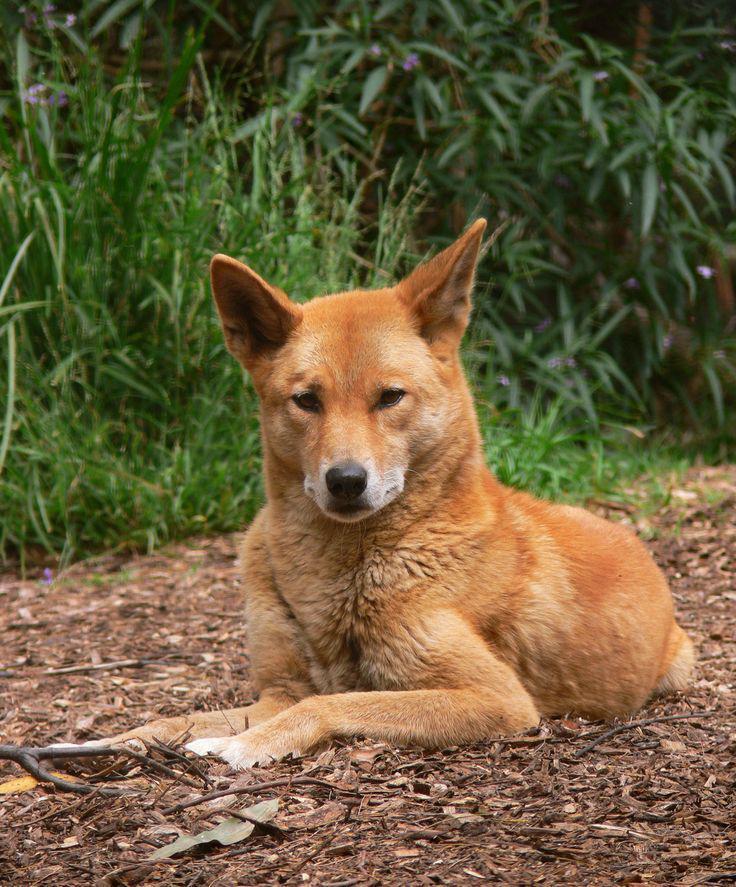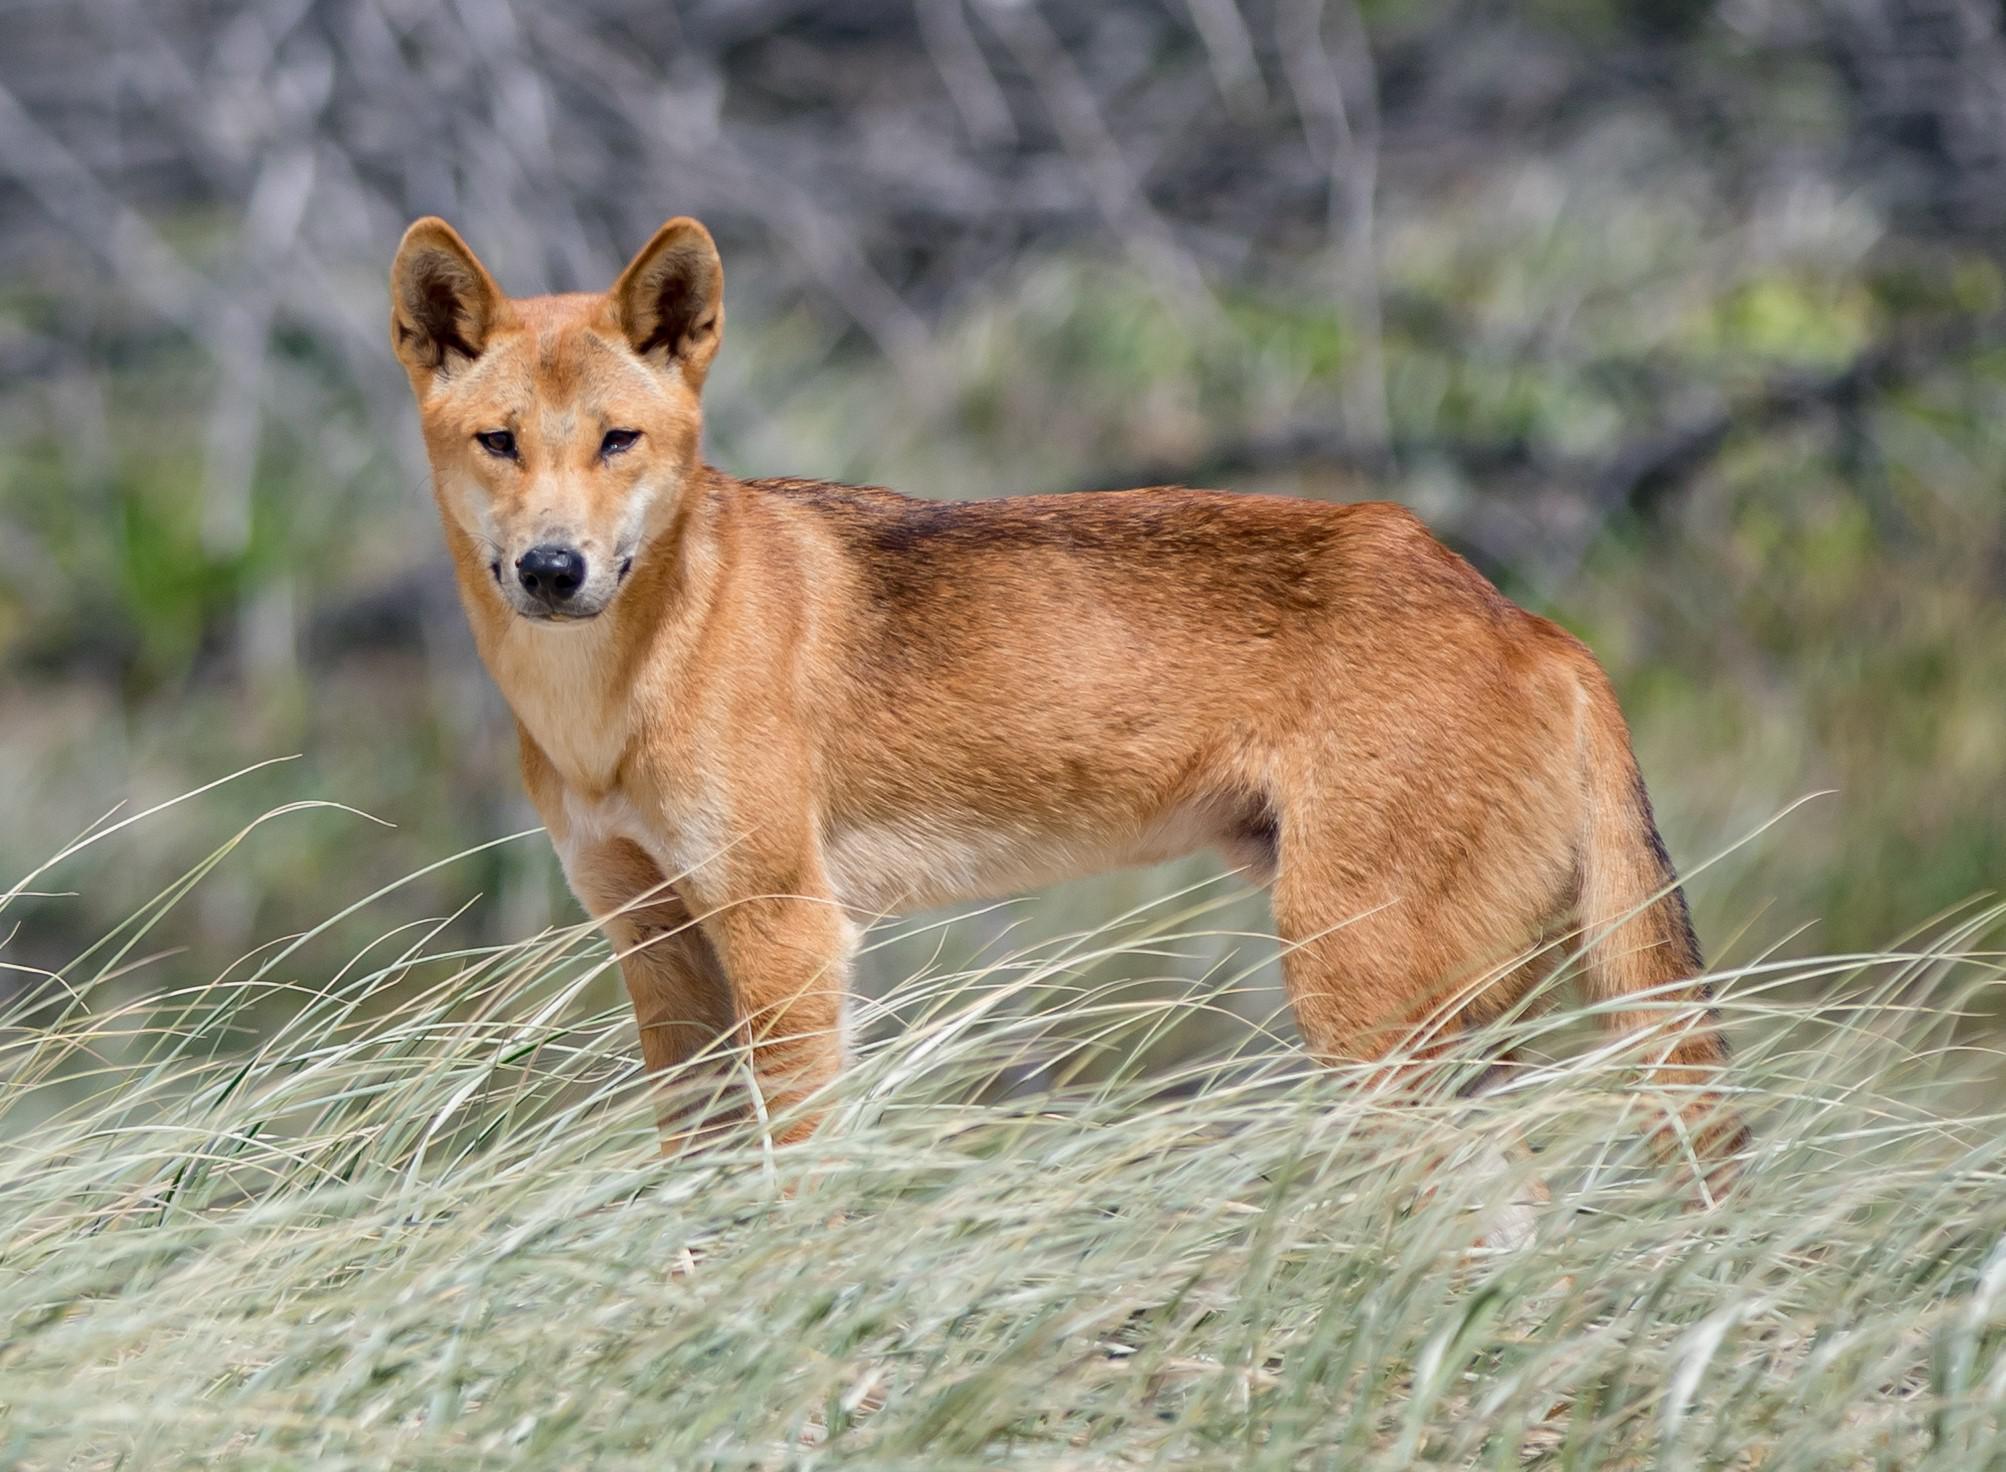The first image is the image on the left, the second image is the image on the right. For the images displayed, is the sentence "The left image contains twice the number of dogs as the right image, and at least two dogs in total are standing." factually correct? Answer yes or no. No. The first image is the image on the left, the second image is the image on the right. Given the left and right images, does the statement "The left image contains exactly two wild dogs." hold true? Answer yes or no. No. 